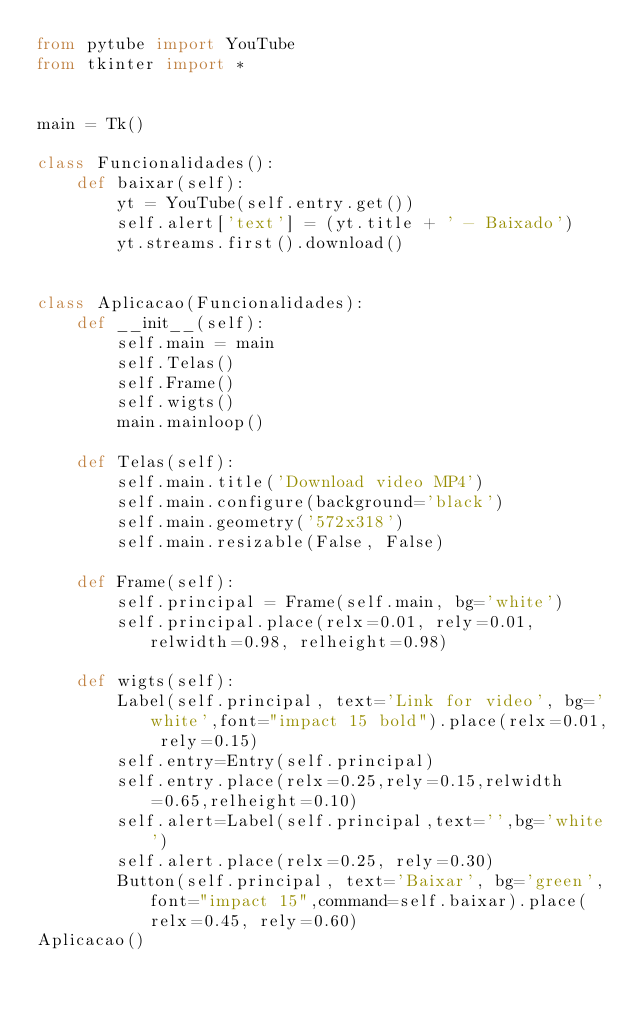Convert code to text. <code><loc_0><loc_0><loc_500><loc_500><_Python_>from pytube import YouTube
from tkinter import *


main = Tk()

class Funcionalidades():
    def baixar(self):
        yt = YouTube(self.entry.get())
        self.alert['text'] = (yt.title + ' - Baixado')
        yt.streams.first().download()


class Aplicacao(Funcionalidades):
    def __init__(self):
        self.main = main
        self.Telas()
        self.Frame()
        self.wigts()
        main.mainloop()

    def Telas(self):
        self.main.title('Download video MP4')
        self.main.configure(background='black')
        self.main.geometry('572x318')
        self.main.resizable(False, False)

    def Frame(self):
        self.principal = Frame(self.main, bg='white')
        self.principal.place(relx=0.01, rely=0.01, relwidth=0.98, relheight=0.98)

    def wigts(self):
        Label(self.principal, text='Link for video', bg='white',font="impact 15 bold").place(relx=0.01, rely=0.15)
        self.entry=Entry(self.principal)
        self.entry.place(relx=0.25,rely=0.15,relwidth=0.65,relheight=0.10)
        self.alert=Label(self.principal,text='',bg='white')
        self.alert.place(relx=0.25, rely=0.30)
        Button(self.principal, text='Baixar', bg='green',font="impact 15",command=self.baixar).place(relx=0.45, rely=0.60)
Aplicacao()
</code> 